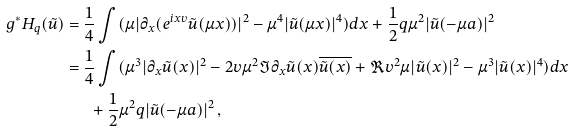<formula> <loc_0><loc_0><loc_500><loc_500>g ^ { * } H _ { q } ( \tilde { u } ) & = \frac { 1 } { 4 } \int ( \mu | \partial _ { x } ( e ^ { i x v } \tilde { u } ( \mu x ) ) | ^ { 2 } - \mu ^ { 4 } | \tilde { u } ( \mu x ) | ^ { 4 } ) d x + \frac { 1 } { 2 } q \mu ^ { 2 } | \tilde { u } ( - \mu a ) | ^ { 2 } \\ & = \frac { 1 } { 4 } \int ( \mu ^ { 3 } | \partial _ { x } \tilde { u } ( x ) | ^ { 2 } - 2 v \mu ^ { 2 } \Im \partial _ { x } \tilde { u } ( x ) \overline { { \tilde { u } } ( x ) } + \Re { v ^ { 2 } } \mu | \tilde { u } ( x ) | ^ { 2 } - \mu ^ { 3 } | \tilde { u } ( x ) | ^ { 4 } ) d x \\ & \quad \ \ + \frac { 1 } { 2 } \mu ^ { 2 } q | \tilde { u } ( - \mu a ) | ^ { 2 } \, ,</formula> 